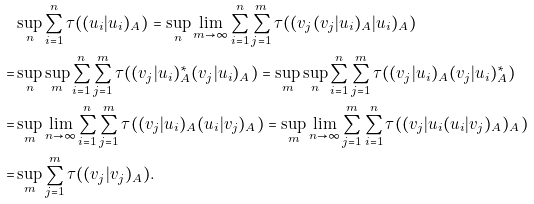Convert formula to latex. <formula><loc_0><loc_0><loc_500><loc_500>& \sup _ { n } \sum _ { i = 1 } ^ { n } \tau ( ( u _ { i } | u _ { i } ) _ { A } ) = \sup _ { n } \lim _ { m \to \infty } \sum _ { i = 1 } ^ { n } \sum _ { j = 1 } ^ { m } \tau ( ( v _ { j } ( v _ { j } | u _ { i } ) _ { A } | u _ { i } ) _ { A } ) \\ = & \sup _ { n } \sup _ { m } \sum _ { i = 1 } ^ { n } \sum _ { j = 1 } ^ { m } \tau ( ( v _ { j } | u _ { i } ) _ { A } ^ { * } ( v _ { j } | u _ { i } ) _ { A } ) = \sup _ { m } \sup _ { n } \sum _ { i = 1 } ^ { n } \sum _ { j = 1 } ^ { m } \tau ( ( v _ { j } | u _ { i } ) _ { A } ( v _ { j } | u _ { i } ) _ { A } ^ { * } ) \\ = & \sup _ { m } \lim _ { n \to \infty } \sum _ { i = 1 } ^ { n } \sum _ { j = 1 } ^ { m } \tau ( ( v _ { j } | u _ { i } ) _ { A } ( u _ { i } | v _ { j } ) _ { A } ) = \sup _ { m } \lim _ { n \to \infty } \sum _ { j = 1 } ^ { m } \sum _ { i = 1 } ^ { n } \tau ( ( v _ { j } | u _ { i } ( u _ { i } | v _ { j } ) _ { A } ) _ { A } ) \\ = & \sup _ { m } \sum _ { j = 1 } ^ { m } \tau ( ( v _ { j } | v _ { j } ) _ { A } ) .</formula> 